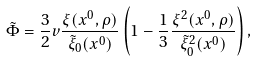Convert formula to latex. <formula><loc_0><loc_0><loc_500><loc_500>\tilde { \Phi } = \frac { 3 } { 2 } v \frac { \xi ( x ^ { 0 } , \rho ) } { \tilde { \xi } _ { 0 } ( x ^ { 0 } ) } \left ( 1 - \frac { 1 } { 3 } \frac { \xi ^ { 2 } ( x ^ { 0 } , \rho ) } { \tilde { \xi } ^ { 2 } _ { 0 } ( x ^ { 0 } ) } \right ) ,</formula> 